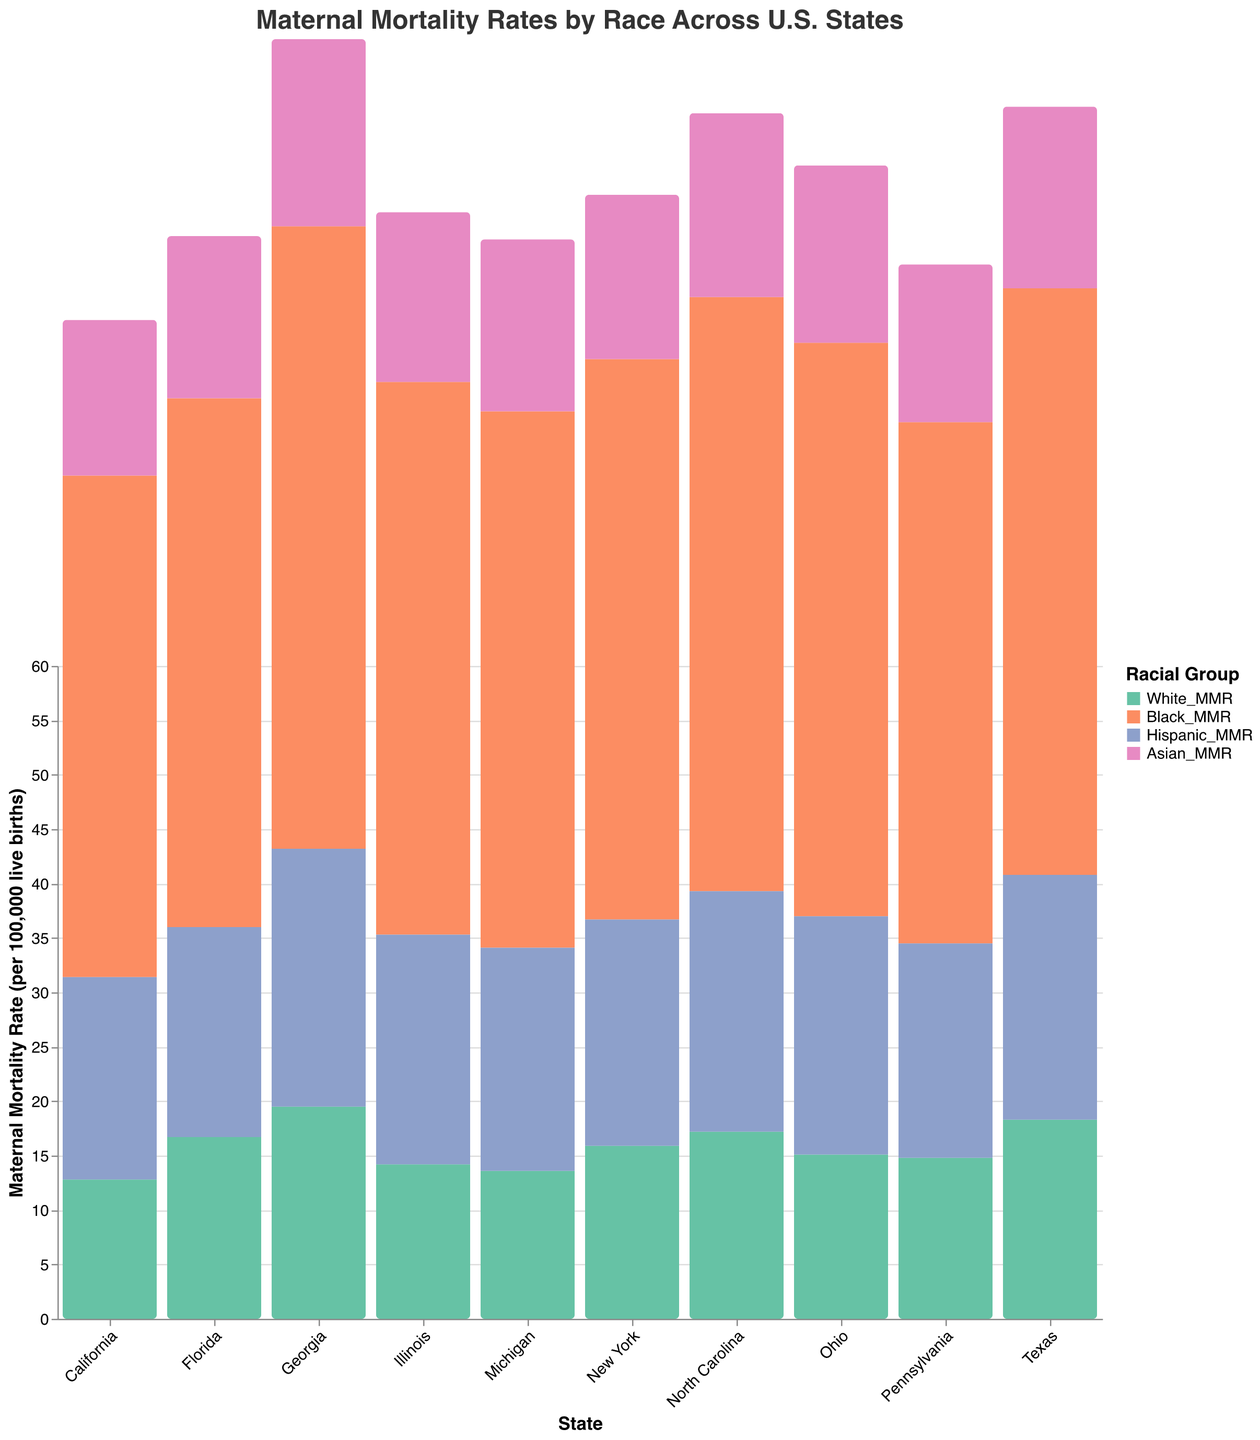What state has the highest maternal mortality rate for Black women? By examining the height of the bars corresponding to Black_MMR, it is clear that Georgia has the highest MMR for Black women at 57.2 per 100,000 live births.
Answer: Georgia Which racial group has the lowest maternal mortality rate in California? The plot shows different bars for each racial group in California, and the bar for White_MMR at 12.8 is the shortest.
Answer: White What's the approximate average maternal mortality rate for Asian women across all listed states? Summing up the MMR values for Asian women across all states and then dividing by the number of states (10): (14.3 + 16.7 + 15.1 + 14.9 + 15.6 + 17.2 + 15.8 + 16.3 + 14.5 + 16.9) / 10 = 15.73.
Answer: 15.7 How much higher is the maternal mortality rate for Hispanic women in Texas compared to Florida? Subtract the MMR for Hispanic women in Florida from the MMR in Texas: 22.5 - 19.3 = 3.2.
Answer: 3.2 Which two states have the closest maternal mortality rates for Black women? By comparing the MMR values for Black women in each state, Florida (48.6) and Pennsylvania (47.9) have the closest values, with a difference of 0.7.
Answer: Florida and Pennsylvania What is the range of maternal mortality rates for White women across all states? Subtract the smallest White_MMR value from the largest: 19.5 (Georgia) - 12.8 (California) = 6.7.
Answer: 6.7 Which state has the highest overall maternal mortality rate across all racial groups? By comparing the tallest bars for each state across all races, Georgia has the highest overall MMR for Black women at 57.2, which is the largest value in the plot.
Answer: Georgia Is the maternal mortality rate for Hispanic women in New York higher or lower than the rate for White women in Texas? By comparing the height of the bars, the MMR for Hispanic women in New York (20.8) is higher than the MMR for White women in Texas (18.3).
Answer: Higher What’s the median maternal mortality rate for Black women across the listed states? Listing the MMR values for Black women in ascending order: 46.1, 47.9, 48.6, 49.3, 50.8, 51.5, 52.7, 53.9, 54.6, 57.2. The middle two values are 50.8 and 51.5, so the median is (50.8 + 51.5) / 2 = 51.15.
Answer: 51.2 Which racial group shows the most consistency in maternal mortality rates across all states? By comparing the variance in the heights of the bars, the Asian group shows the least variation, indicating the most consistency in their MMR.
Answer: Asian 